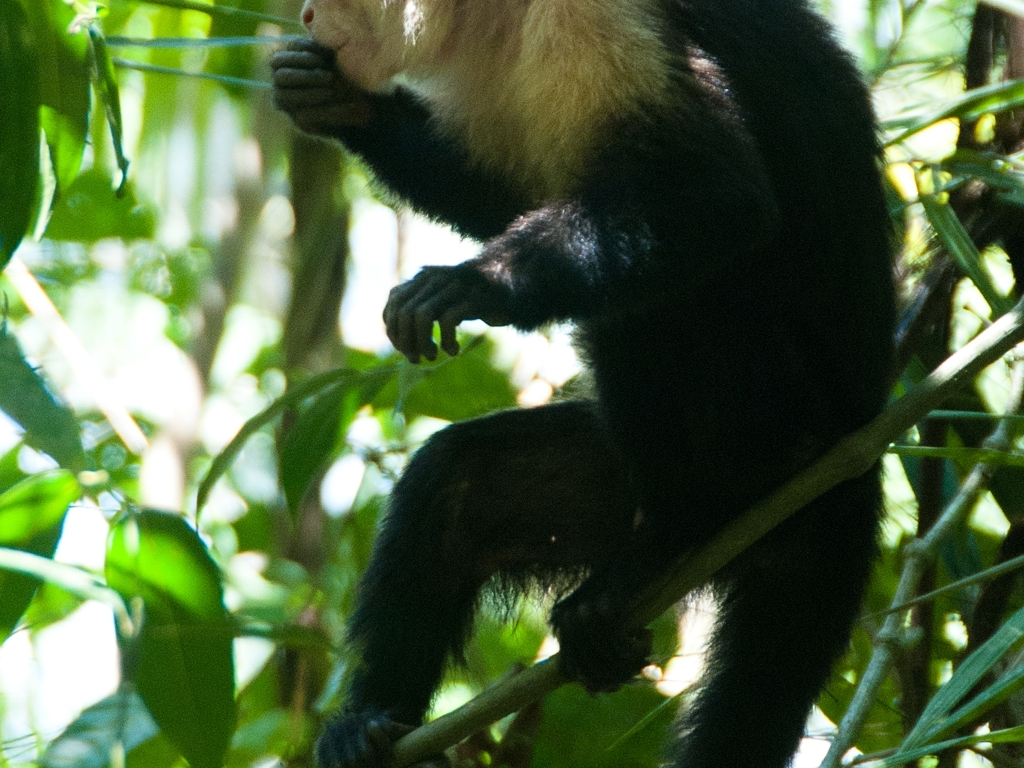Is the fur of the animals clear?
A. Yes
B. No While it's apparent that the image shows an animal with fur, the clarity of the fur is compromised due to the shadowy and complex natural lighting within the animal's habitat. However, some detail in the fur's texture and color variation can still be discerned. Therefore, in a more nuanced answer to the question of fur clarity: it is partially clear but also affected by the lighting conditions. 